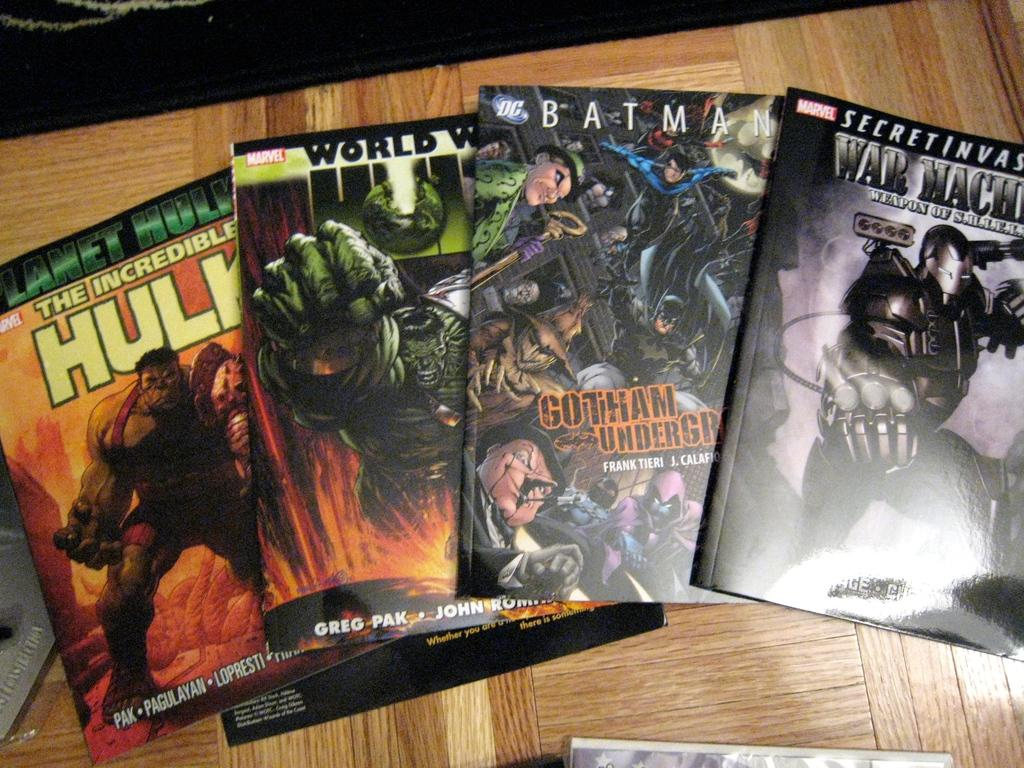<image>
Create a compact narrative representing the image presented. Multiple comic books including the Hulk, Batman and Warmachine. 